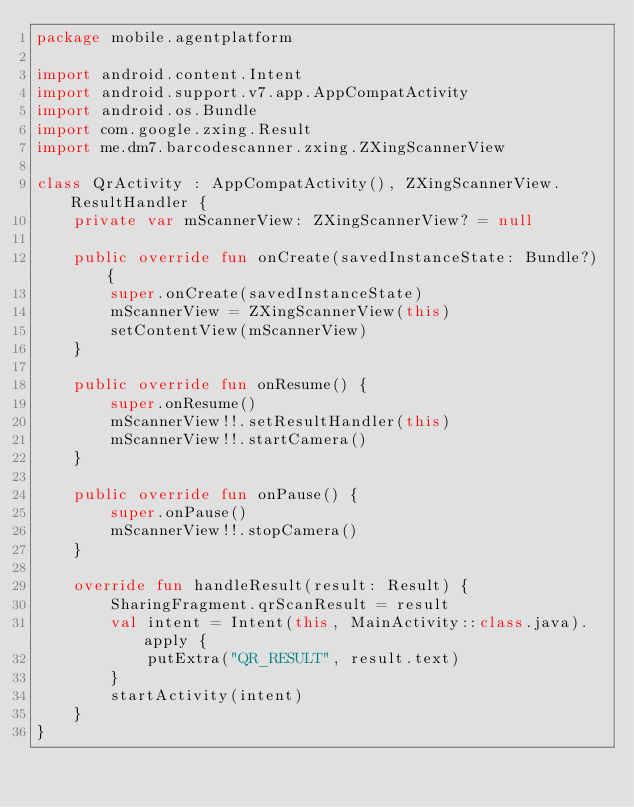<code> <loc_0><loc_0><loc_500><loc_500><_Kotlin_>package mobile.agentplatform

import android.content.Intent
import android.support.v7.app.AppCompatActivity
import android.os.Bundle
import com.google.zxing.Result
import me.dm7.barcodescanner.zxing.ZXingScannerView

class QrActivity : AppCompatActivity(), ZXingScannerView.ResultHandler {
    private var mScannerView: ZXingScannerView? = null

    public override fun onCreate(savedInstanceState: Bundle?) {
        super.onCreate(savedInstanceState)
        mScannerView = ZXingScannerView(this)
        setContentView(mScannerView)
    }

    public override fun onResume() {
        super.onResume()
        mScannerView!!.setResultHandler(this)
        mScannerView!!.startCamera()
    }

    public override fun onPause() {
        super.onPause()
        mScannerView!!.stopCamera()
    }

    override fun handleResult(result: Result) {
        SharingFragment.qrScanResult = result
        val intent = Intent(this, MainActivity::class.java).apply {
            putExtra("QR_RESULT", result.text)
        }
        startActivity(intent)
    }
}
</code> 